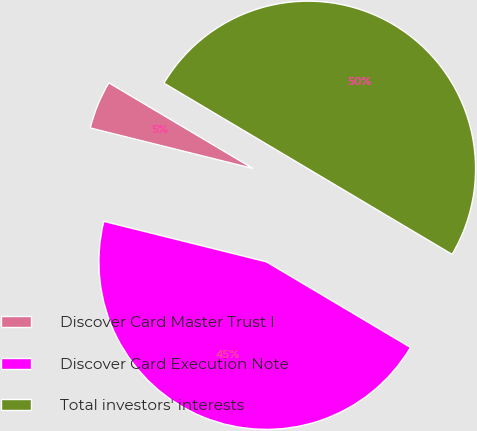Convert chart. <chart><loc_0><loc_0><loc_500><loc_500><pie_chart><fcel>Discover Card Master Trust I<fcel>Discover Card Execution Note<fcel>Total investors' interests<nl><fcel>4.65%<fcel>45.35%<fcel>50.0%<nl></chart> 